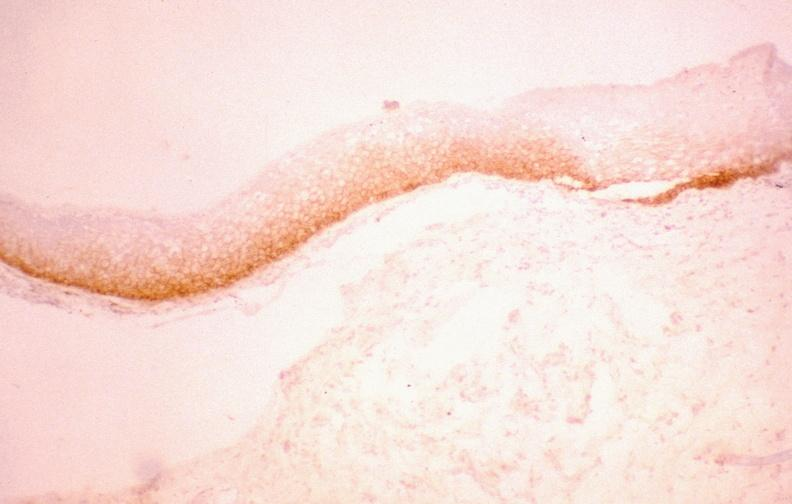s gastrointestinal present?
Answer the question using a single word or phrase. Yes 